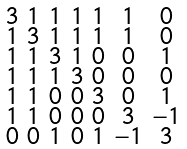<formula> <loc_0><loc_0><loc_500><loc_500>\begin{smallmatrix} 3 & 1 & 1 & 1 & 1 & 1 & 0 \\ 1 & 3 & 1 & 1 & 1 & 1 & 0 \\ 1 & 1 & 3 & 1 & 0 & 0 & 1 \\ 1 & 1 & 1 & 3 & 0 & 0 & 0 \\ 1 & 1 & 0 & 0 & 3 & 0 & 1 \\ 1 & 1 & 0 & 0 & 0 & 3 & - 1 \\ 0 & 0 & 1 & 0 & 1 & - 1 & 3 \end{smallmatrix}</formula> 